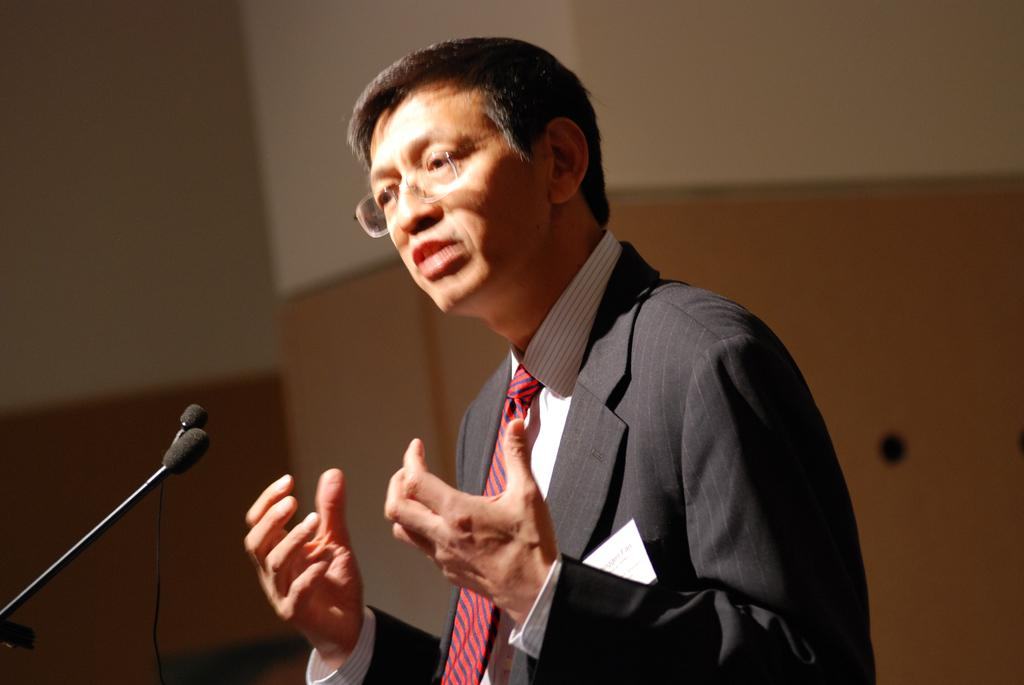What is present in the image? There is a person in the image. Can you describe the person's appearance? The person is wearing clothes and spectacles. What else can be seen in the image? There are mice in the bottom left of the image. How would you describe the background of the image? The background of the image is blurred. What type of pie is being served on the hook in the image? There is no pie or hook present in the image. 